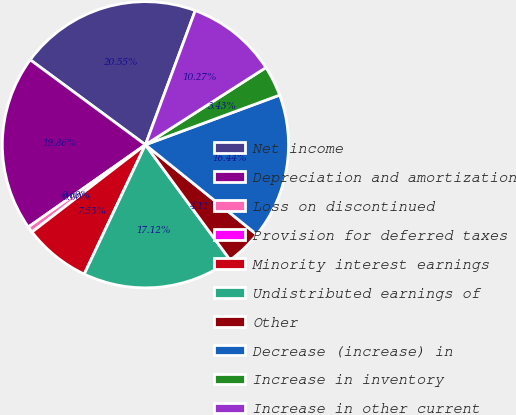<chart> <loc_0><loc_0><loc_500><loc_500><pie_chart><fcel>Net income<fcel>Depreciation and amortization<fcel>Loss on discontinued<fcel>Provision for deferred taxes<fcel>Minority interest earnings<fcel>Undistributed earnings of<fcel>Other<fcel>Decrease (increase) in<fcel>Increase in inventory<fcel>Increase in other current<nl><fcel>20.55%<fcel>19.86%<fcel>0.69%<fcel>0.0%<fcel>7.53%<fcel>17.12%<fcel>4.11%<fcel>16.44%<fcel>3.43%<fcel>10.27%<nl></chart> 